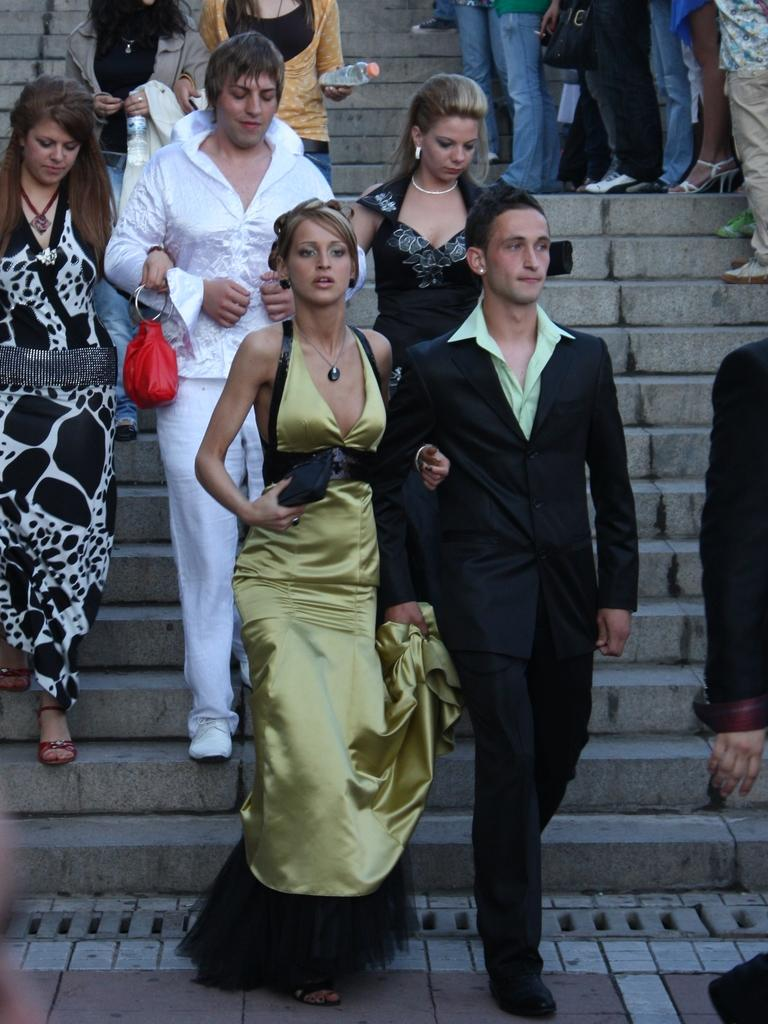What is the main subject of the image? The main subject of the image is a group of people. What are some of the people in the group doing? Some people in the group are standing, while others are walking on steps. Can you tell me how many docks are visible in the image? There are no docks present in the image. What type of news can be heard coming from the people in the image? There is no indication in the image that the people are discussing or sharing any news. 